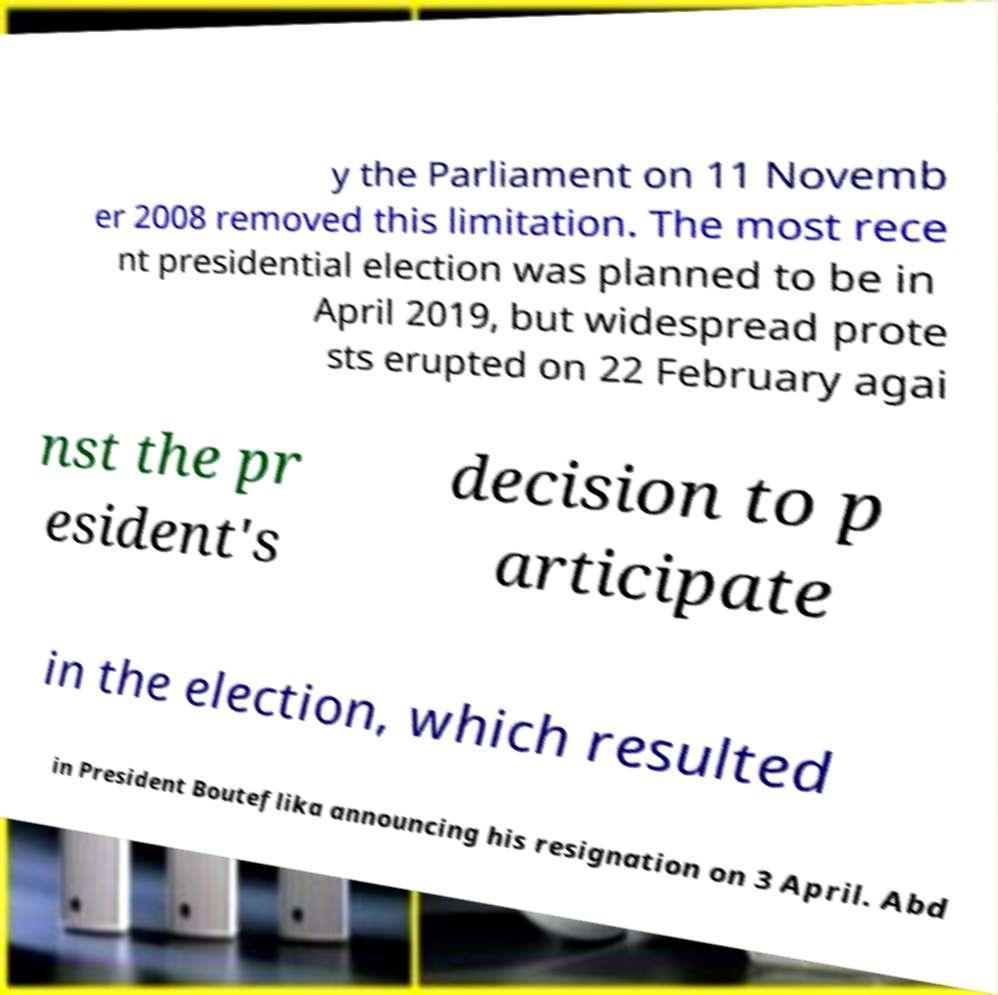Please read and relay the text visible in this image. What does it say? y the Parliament on 11 Novemb er 2008 removed this limitation. The most rece nt presidential election was planned to be in April 2019, but widespread prote sts erupted on 22 February agai nst the pr esident's decision to p articipate in the election, which resulted in President Bouteflika announcing his resignation on 3 April. Abd 